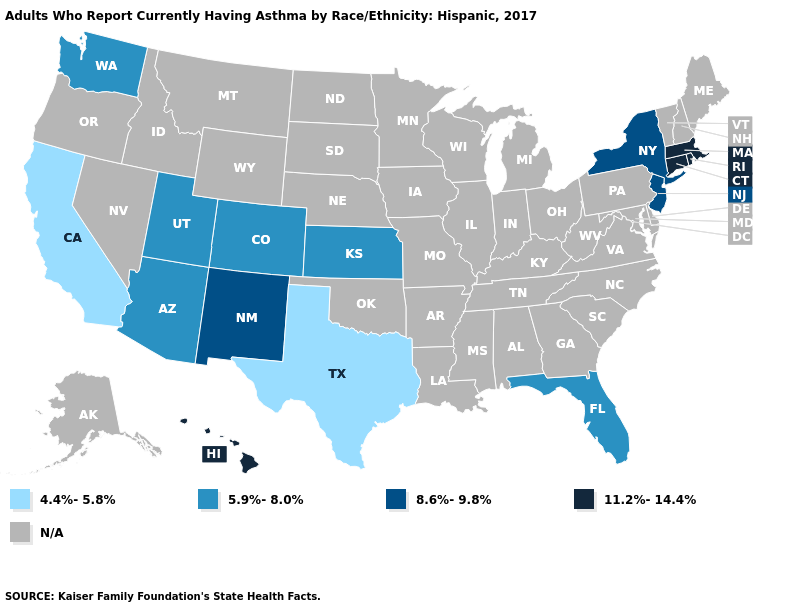Name the states that have a value in the range 8.6%-9.8%?
Give a very brief answer. New Jersey, New Mexico, New York. Which states have the lowest value in the Northeast?
Concise answer only. New Jersey, New York. What is the value of Mississippi?
Give a very brief answer. N/A. Among the states that border Alabama , which have the lowest value?
Concise answer only. Florida. What is the highest value in the West ?
Write a very short answer. 11.2%-14.4%. Does Massachusetts have the highest value in the USA?
Quick response, please. Yes. What is the lowest value in the South?
Quick response, please. 4.4%-5.8%. Does Utah have the lowest value in the West?
Keep it brief. No. Does Texas have the lowest value in the USA?
Give a very brief answer. Yes. What is the lowest value in the USA?
Give a very brief answer. 4.4%-5.8%. 